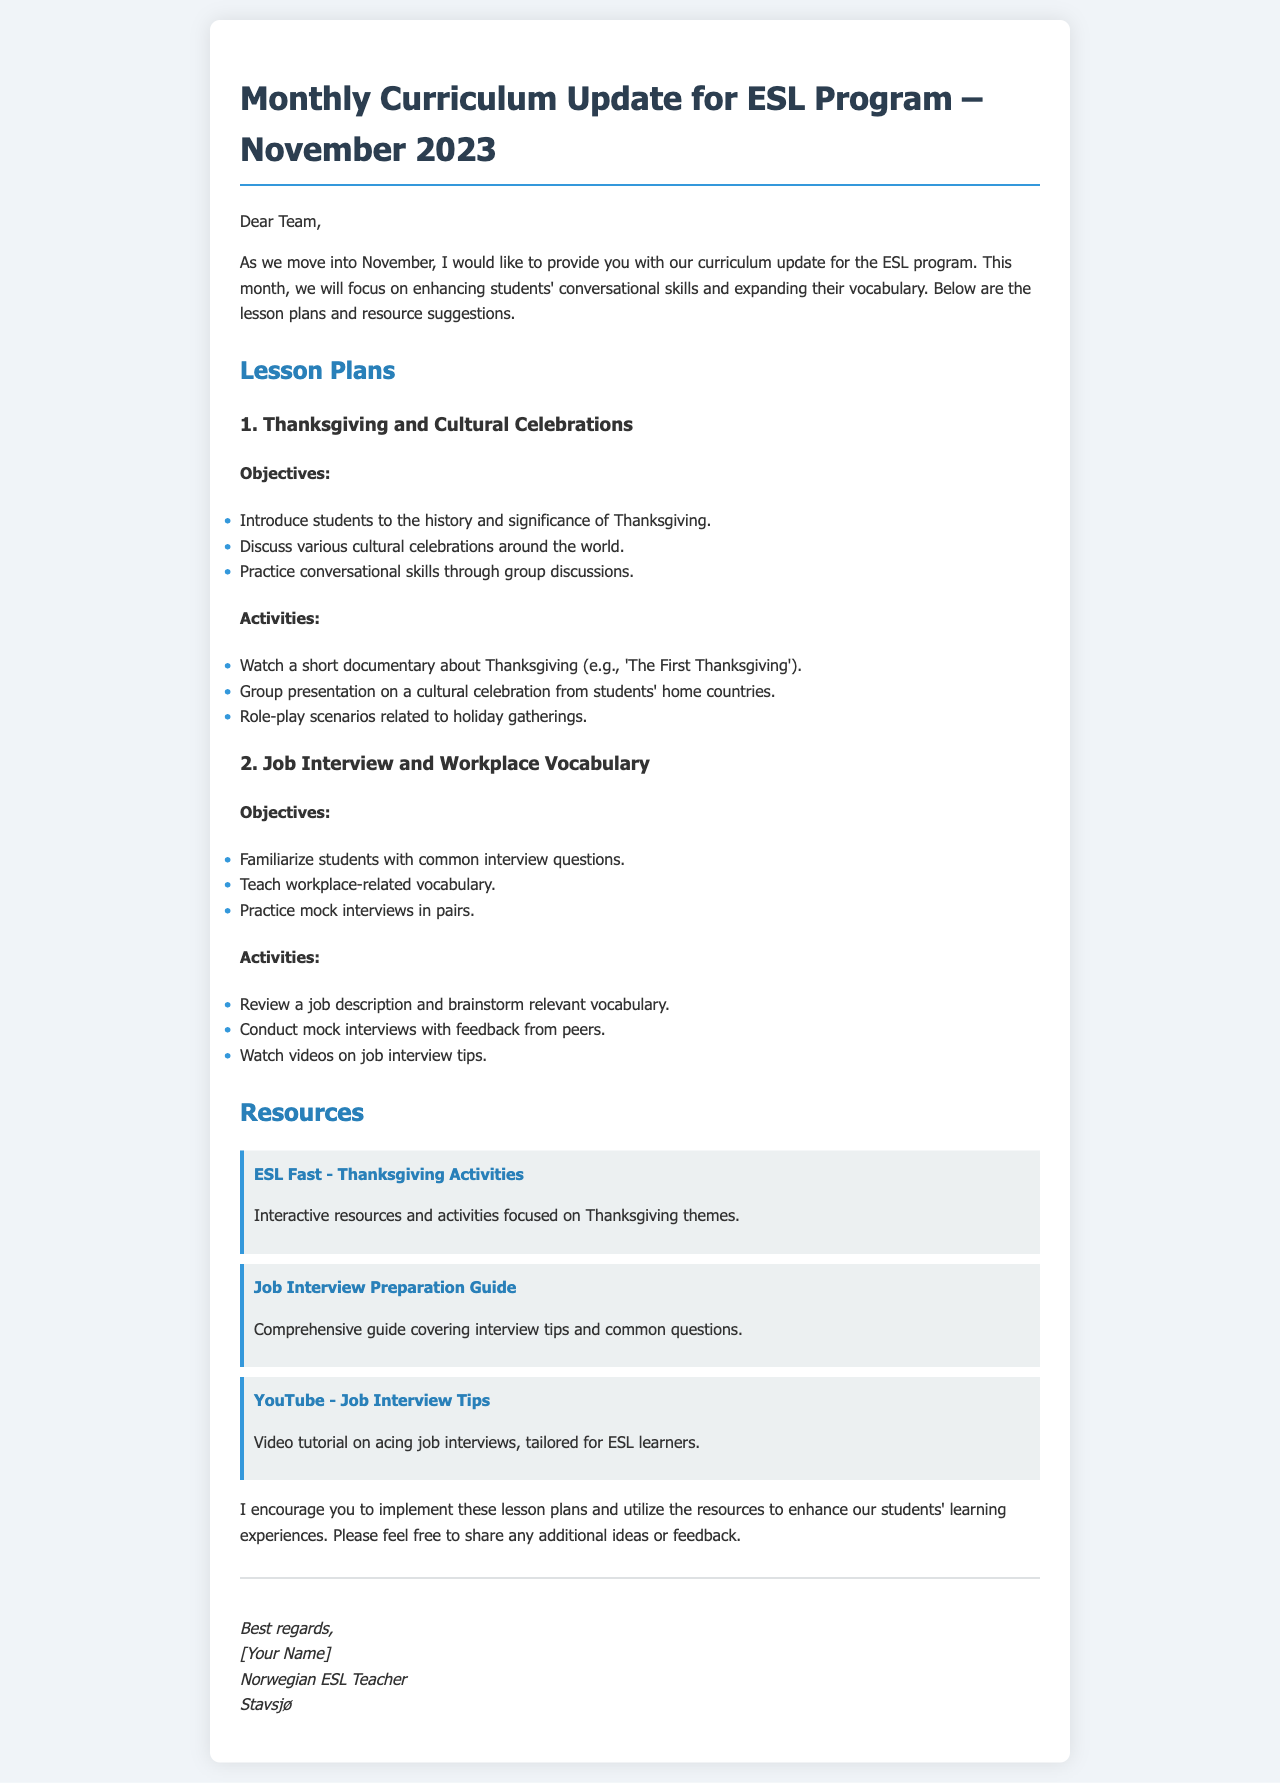What is the main focus of the ESL program in November 2023? The main focus is on enhancing students' conversational skills and expanding their vocabulary.
Answer: Conversational skills and vocabulary What is one of the objectives of the lesson plan concerning Thanksgiving? The lesson plan includes multiple objectives, one of which is to introduce students to the history and significance of Thanksgiving.
Answer: History and significance of Thanksgiving What activity involves group discussions? The objective of enhancing conversational skills is achieved through a specific activity that emphasizes group discussions.
Answer: Group discussions How many lesson plans are provided in the document? The document lists two lesson plans, each with its objectives and activities outlined.
Answer: Two What type of resource is linked for Thanksgiving activities? The resource provided is an interactive platform focused on Thanksgiving themes.
Answer: Interactive resources Which platform provides a job interview preparation guide? The document references a specific online guide that helps with job interview preparation.
Answer: The Balance Careers What is the total number of activities listed for the job interview lesson plan? The activities section of the job interview lesson plan includes three specific activities outlined.
Answer: Three Who is the author of the email? The author introduces themselves at the end of the email with their title and location.
Answer: [Your Name] What kind of teaching does the email aim to enhance? The document's purpose is to provide updates and encourage the use of specific resources to improve teaching effectiveness.
Answer: Teaching experiences 